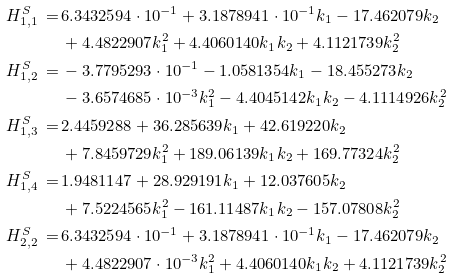<formula> <loc_0><loc_0><loc_500><loc_500>H ^ { S } _ { 1 , 1 } \, = \, & 6 . 3 4 3 2 5 9 4 \cdot 1 0 ^ { - 1 } + 3 . 1 8 7 8 9 4 1 \cdot 1 0 ^ { - 1 } k _ { 1 } - 1 7 . 4 6 2 0 7 9 k _ { 2 } \\ & + 4 . 4 8 2 2 9 0 7 k _ { 1 } ^ { 2 } + 4 . 4 0 6 0 1 4 0 k _ { 1 } k _ { 2 } + 4 . 1 1 2 1 7 3 9 k _ { 2 } ^ { 2 } \\ H ^ { S } _ { 1 , 2 } \, = \, & - 3 . 7 7 9 5 2 9 3 \cdot 1 0 ^ { - 1 } - 1 . 0 5 8 1 3 5 4 k _ { 1 } - 1 8 . 4 5 5 2 7 3 k _ { 2 } \\ & - 3 . 6 5 7 4 6 8 5 \cdot 1 0 ^ { - 3 } k _ { 1 } ^ { 2 } - 4 . 4 0 4 5 1 4 2 k _ { 1 } k _ { 2 } - 4 . 1 1 1 4 9 2 6 k _ { 2 } ^ { 2 } \\ H ^ { S } _ { 1 , 3 } \, = \, & 2 . 4 4 5 9 2 8 8 + 3 6 . 2 8 5 6 3 9 k _ { 1 } + 4 2 . 6 1 9 2 2 0 k _ { 2 } \\ & + 7 . 8 4 5 9 7 2 9 k _ { 1 } ^ { 2 } + 1 8 9 . 0 6 1 3 9 k _ { 1 } k _ { 2 } + 1 6 9 . 7 7 3 2 4 k _ { 2 } ^ { 2 } \\ H ^ { S } _ { 1 , 4 } \, = \, & 1 . 9 4 8 1 1 4 7 + 2 8 . 9 2 9 1 9 1 k _ { 1 } + 1 2 . 0 3 7 6 0 5 k _ { 2 } \\ & + 7 . 5 2 2 4 5 6 5 k _ { 1 } ^ { 2 } - 1 6 1 . 1 1 4 8 7 k _ { 1 } k _ { 2 } - 1 5 7 . 0 7 8 0 8 k _ { 2 } ^ { 2 } \\ H ^ { S } _ { 2 , 2 } \, = \, & 6 . 3 4 3 2 5 9 4 \cdot 1 0 ^ { - 1 } + 3 . 1 8 7 8 9 4 1 \cdot 1 0 ^ { - 1 } k _ { 1 } - 1 7 . 4 6 2 0 7 9 k _ { 2 } \\ & + 4 . 4 8 2 2 9 0 7 \cdot 1 0 ^ { - 3 } k _ { 1 } ^ { 2 } + 4 . 4 0 6 0 1 4 0 k _ { 1 } k _ { 2 } + 4 . 1 1 2 1 7 3 9 k _ { 2 } ^ { 2 } \\</formula> 